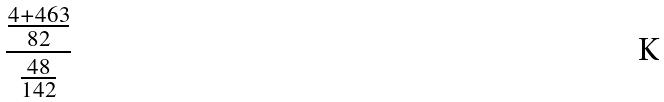Convert formula to latex. <formula><loc_0><loc_0><loc_500><loc_500>\frac { \frac { 4 + 4 6 3 } { 8 2 } } { \frac { 4 8 } { 1 4 2 } }</formula> 